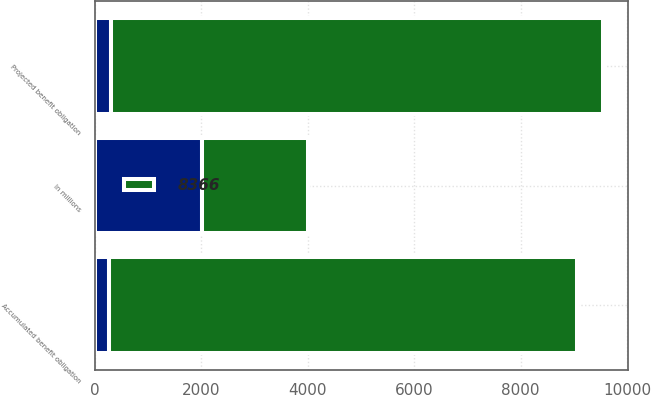Convert chart. <chart><loc_0><loc_0><loc_500><loc_500><stacked_bar_chart><ecel><fcel>In millions<fcel>Projected benefit obligation<fcel>Accumulated benefit obligation<nl><fcel>nan<fcel>2007<fcel>307<fcel>261<nl><fcel>8366<fcel>2006<fcel>9237<fcel>8801<nl></chart> 